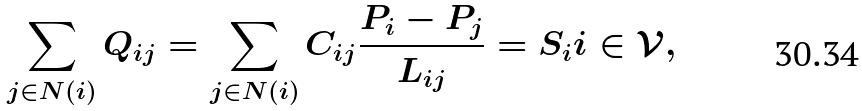Convert formula to latex. <formula><loc_0><loc_0><loc_500><loc_500>\sum _ { j \in N ( i ) } Q _ { i j } = \sum _ { j \in N ( i ) } C _ { i j } \frac { P _ { i } - P _ { j } } { L _ { i j } } = S _ { i } i \in \mathcal { V } ,</formula> 